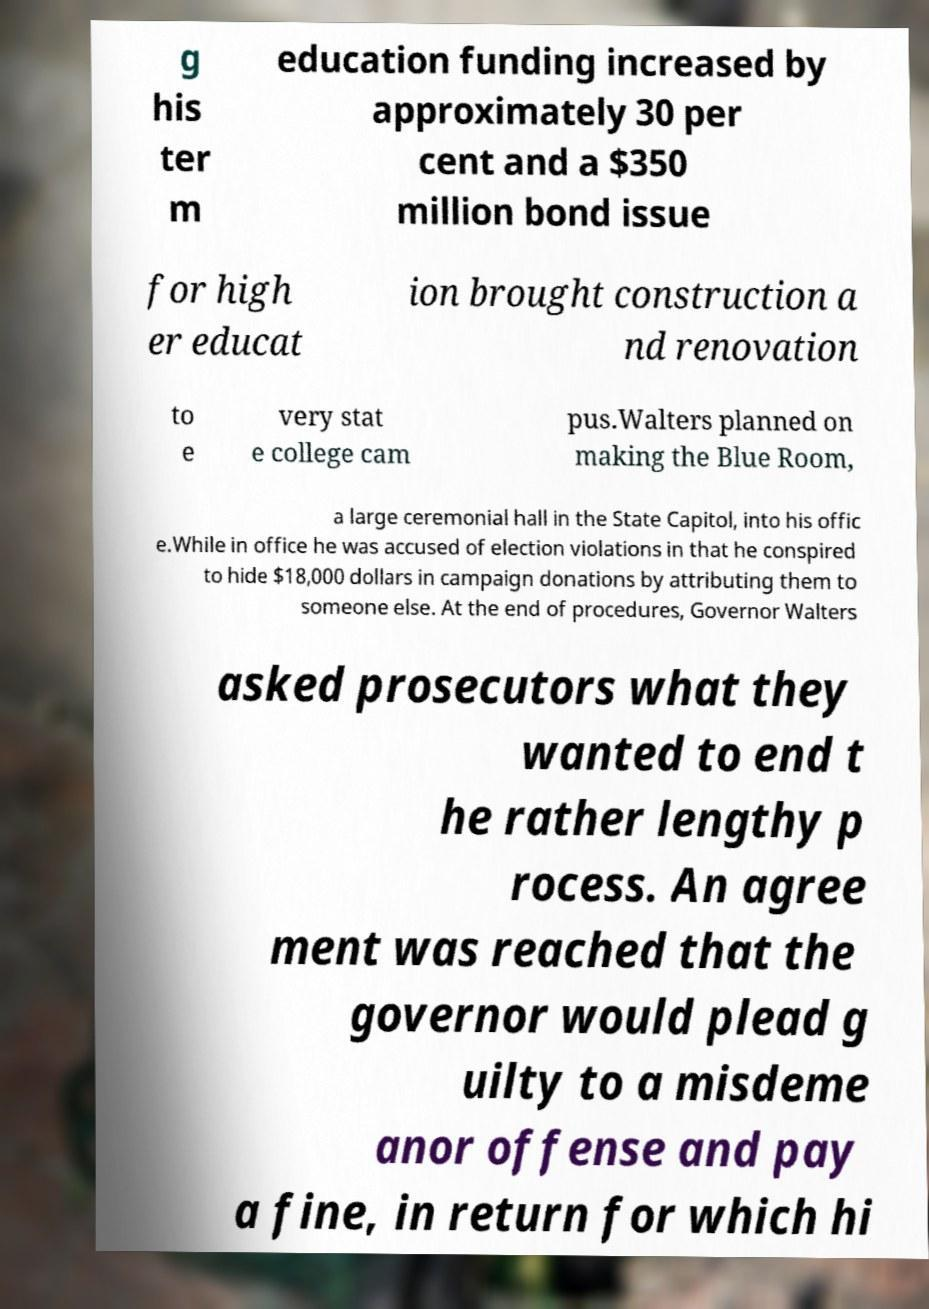Please read and relay the text visible in this image. What does it say? g his ter m education funding increased by approximately 30 per cent and a $350 million bond issue for high er educat ion brought construction a nd renovation to e very stat e college cam pus.Walters planned on making the Blue Room, a large ceremonial hall in the State Capitol, into his offic e.While in office he was accused of election violations in that he conspired to hide $18,000 dollars in campaign donations by attributing them to someone else. At the end of procedures, Governor Walters asked prosecutors what they wanted to end t he rather lengthy p rocess. An agree ment was reached that the governor would plead g uilty to a misdeme anor offense and pay a fine, in return for which hi 